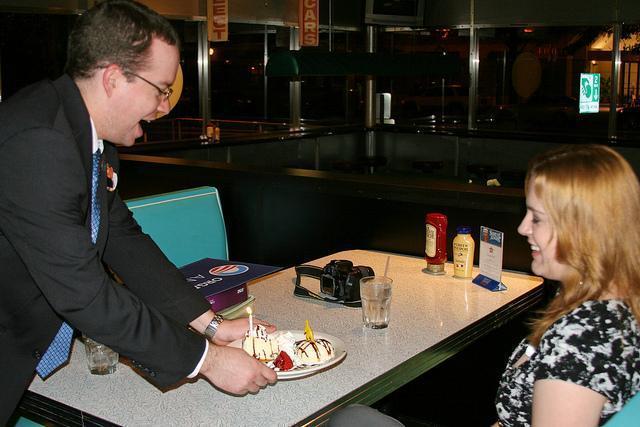How many candles are in this image?
Give a very brief answer. 1. How many chairs can you see?
Give a very brief answer. 1. How many cakes can you see?
Give a very brief answer. 1. How many people are there?
Give a very brief answer. 2. 